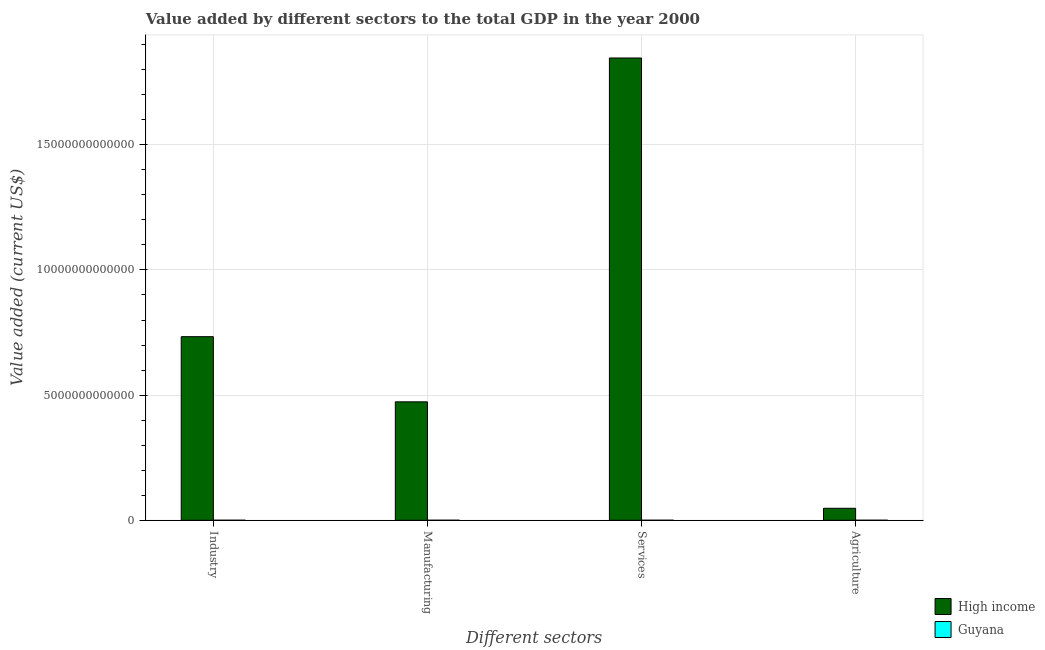How many different coloured bars are there?
Provide a short and direct response. 2. How many groups of bars are there?
Provide a succinct answer. 4. Are the number of bars per tick equal to the number of legend labels?
Offer a terse response. Yes. Are the number of bars on each tick of the X-axis equal?
Your response must be concise. Yes. How many bars are there on the 2nd tick from the left?
Offer a very short reply. 2. What is the label of the 3rd group of bars from the left?
Give a very brief answer. Services. What is the value added by agricultural sector in High income?
Your response must be concise. 4.79e+11. Across all countries, what is the maximum value added by services sector?
Provide a succinct answer. 1.85e+13. Across all countries, what is the minimum value added by industrial sector?
Offer a very short reply. 1.72e+08. In which country was the value added by manufacturing sector minimum?
Ensure brevity in your answer.  Guyana. What is the total value added by manufacturing sector in the graph?
Provide a short and direct response. 4.73e+12. What is the difference between the value added by services sector in Guyana and that in High income?
Offer a terse response. -1.85e+13. What is the difference between the value added by services sector in Guyana and the value added by industrial sector in High income?
Offer a very short reply. -7.33e+12. What is the average value added by services sector per country?
Provide a short and direct response. 9.23e+12. What is the difference between the value added by industrial sector and value added by services sector in High income?
Your answer should be compact. -1.11e+13. In how many countries, is the value added by services sector greater than 1000000000000 US$?
Give a very brief answer. 1. What is the ratio of the value added by industrial sector in Guyana to that in High income?
Provide a succinct answer. 2.3455100641738678e-5. What is the difference between the highest and the second highest value added by services sector?
Make the answer very short. 1.85e+13. What is the difference between the highest and the lowest value added by services sector?
Ensure brevity in your answer.  1.85e+13. Is the sum of the value added by industrial sector in High income and Guyana greater than the maximum value added by manufacturing sector across all countries?
Offer a very short reply. Yes. How many bars are there?
Make the answer very short. 8. What is the difference between two consecutive major ticks on the Y-axis?
Your answer should be very brief. 5.00e+12. Does the graph contain any zero values?
Offer a terse response. No. Does the graph contain grids?
Offer a terse response. Yes. Where does the legend appear in the graph?
Your answer should be very brief. Bottom right. What is the title of the graph?
Keep it short and to the point. Value added by different sectors to the total GDP in the year 2000. Does "South Africa" appear as one of the legend labels in the graph?
Your answer should be very brief. No. What is the label or title of the X-axis?
Keep it short and to the point. Different sectors. What is the label or title of the Y-axis?
Make the answer very short. Value added (current US$). What is the Value added (current US$) of High income in Industry?
Your answer should be compact. 7.33e+12. What is the Value added (current US$) of Guyana in Industry?
Give a very brief answer. 1.72e+08. What is the Value added (current US$) in High income in Manufacturing?
Keep it short and to the point. 4.73e+12. What is the Value added (current US$) of Guyana in Manufacturing?
Offer a very short reply. 4.83e+07. What is the Value added (current US$) of High income in Services?
Offer a very short reply. 1.85e+13. What is the Value added (current US$) in Guyana in Services?
Your answer should be compact. 2.36e+08. What is the Value added (current US$) of High income in Agriculture?
Provide a succinct answer. 4.79e+11. What is the Value added (current US$) in Guyana in Agriculture?
Your response must be concise. 1.84e+08. Across all Different sectors, what is the maximum Value added (current US$) of High income?
Your answer should be compact. 1.85e+13. Across all Different sectors, what is the maximum Value added (current US$) in Guyana?
Your answer should be very brief. 2.36e+08. Across all Different sectors, what is the minimum Value added (current US$) in High income?
Keep it short and to the point. 4.79e+11. Across all Different sectors, what is the minimum Value added (current US$) of Guyana?
Give a very brief answer. 4.83e+07. What is the total Value added (current US$) of High income in the graph?
Provide a succinct answer. 3.10e+13. What is the total Value added (current US$) in Guyana in the graph?
Offer a very short reply. 6.41e+08. What is the difference between the Value added (current US$) of High income in Industry and that in Manufacturing?
Your answer should be compact. 2.60e+12. What is the difference between the Value added (current US$) of Guyana in Industry and that in Manufacturing?
Provide a succinct answer. 1.24e+08. What is the difference between the Value added (current US$) in High income in Industry and that in Services?
Your answer should be very brief. -1.11e+13. What is the difference between the Value added (current US$) in Guyana in Industry and that in Services?
Your answer should be very brief. -6.42e+07. What is the difference between the Value added (current US$) in High income in Industry and that in Agriculture?
Your answer should be compact. 6.86e+12. What is the difference between the Value added (current US$) of Guyana in Industry and that in Agriculture?
Ensure brevity in your answer.  -1.22e+07. What is the difference between the Value added (current US$) of High income in Manufacturing and that in Services?
Ensure brevity in your answer.  -1.37e+13. What is the difference between the Value added (current US$) in Guyana in Manufacturing and that in Services?
Your answer should be compact. -1.88e+08. What is the difference between the Value added (current US$) of High income in Manufacturing and that in Agriculture?
Offer a very short reply. 4.25e+12. What is the difference between the Value added (current US$) of Guyana in Manufacturing and that in Agriculture?
Your answer should be compact. -1.36e+08. What is the difference between the Value added (current US$) of High income in Services and that in Agriculture?
Provide a succinct answer. 1.80e+13. What is the difference between the Value added (current US$) in Guyana in Services and that in Agriculture?
Your response must be concise. 5.21e+07. What is the difference between the Value added (current US$) in High income in Industry and the Value added (current US$) in Guyana in Manufacturing?
Offer a terse response. 7.33e+12. What is the difference between the Value added (current US$) in High income in Industry and the Value added (current US$) in Guyana in Services?
Your answer should be compact. 7.33e+12. What is the difference between the Value added (current US$) of High income in Industry and the Value added (current US$) of Guyana in Agriculture?
Your answer should be very brief. 7.33e+12. What is the difference between the Value added (current US$) in High income in Manufacturing and the Value added (current US$) in Guyana in Services?
Your answer should be compact. 4.73e+12. What is the difference between the Value added (current US$) of High income in Manufacturing and the Value added (current US$) of Guyana in Agriculture?
Provide a succinct answer. 4.73e+12. What is the difference between the Value added (current US$) of High income in Services and the Value added (current US$) of Guyana in Agriculture?
Your response must be concise. 1.85e+13. What is the average Value added (current US$) in High income per Different sectors?
Your answer should be very brief. 7.75e+12. What is the average Value added (current US$) in Guyana per Different sectors?
Your answer should be very brief. 1.60e+08. What is the difference between the Value added (current US$) of High income and Value added (current US$) of Guyana in Industry?
Your response must be concise. 7.33e+12. What is the difference between the Value added (current US$) of High income and Value added (current US$) of Guyana in Manufacturing?
Your answer should be very brief. 4.73e+12. What is the difference between the Value added (current US$) of High income and Value added (current US$) of Guyana in Services?
Make the answer very short. 1.85e+13. What is the difference between the Value added (current US$) of High income and Value added (current US$) of Guyana in Agriculture?
Make the answer very short. 4.78e+11. What is the ratio of the Value added (current US$) of High income in Industry to that in Manufacturing?
Provide a short and direct response. 1.55. What is the ratio of the Value added (current US$) of Guyana in Industry to that in Manufacturing?
Provide a short and direct response. 3.56. What is the ratio of the Value added (current US$) of High income in Industry to that in Services?
Your answer should be very brief. 0.4. What is the ratio of the Value added (current US$) in Guyana in Industry to that in Services?
Give a very brief answer. 0.73. What is the ratio of the Value added (current US$) in High income in Industry to that in Agriculture?
Your response must be concise. 15.32. What is the ratio of the Value added (current US$) in Guyana in Industry to that in Agriculture?
Make the answer very short. 0.93. What is the ratio of the Value added (current US$) of High income in Manufacturing to that in Services?
Make the answer very short. 0.26. What is the ratio of the Value added (current US$) of Guyana in Manufacturing to that in Services?
Give a very brief answer. 0.2. What is the ratio of the Value added (current US$) of High income in Manufacturing to that in Agriculture?
Provide a short and direct response. 9.89. What is the ratio of the Value added (current US$) of Guyana in Manufacturing to that in Agriculture?
Your answer should be compact. 0.26. What is the ratio of the Value added (current US$) of High income in Services to that in Agriculture?
Your response must be concise. 38.59. What is the ratio of the Value added (current US$) in Guyana in Services to that in Agriculture?
Make the answer very short. 1.28. What is the difference between the highest and the second highest Value added (current US$) in High income?
Make the answer very short. 1.11e+13. What is the difference between the highest and the second highest Value added (current US$) of Guyana?
Give a very brief answer. 5.21e+07. What is the difference between the highest and the lowest Value added (current US$) of High income?
Ensure brevity in your answer.  1.80e+13. What is the difference between the highest and the lowest Value added (current US$) of Guyana?
Provide a short and direct response. 1.88e+08. 